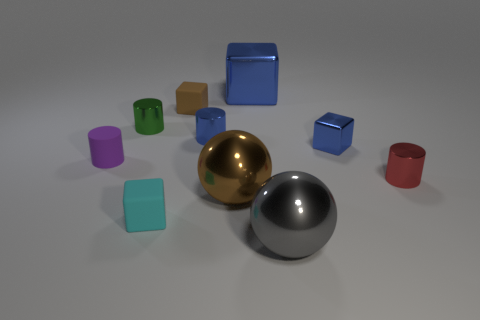Subtract all cylinders. How many objects are left? 6 Add 7 purple rubber blocks. How many purple rubber blocks exist? 7 Subtract 0 cyan cylinders. How many objects are left? 10 Subtract all big blue metallic cylinders. Subtract all small shiny cylinders. How many objects are left? 7 Add 1 red metal things. How many red metal things are left? 2 